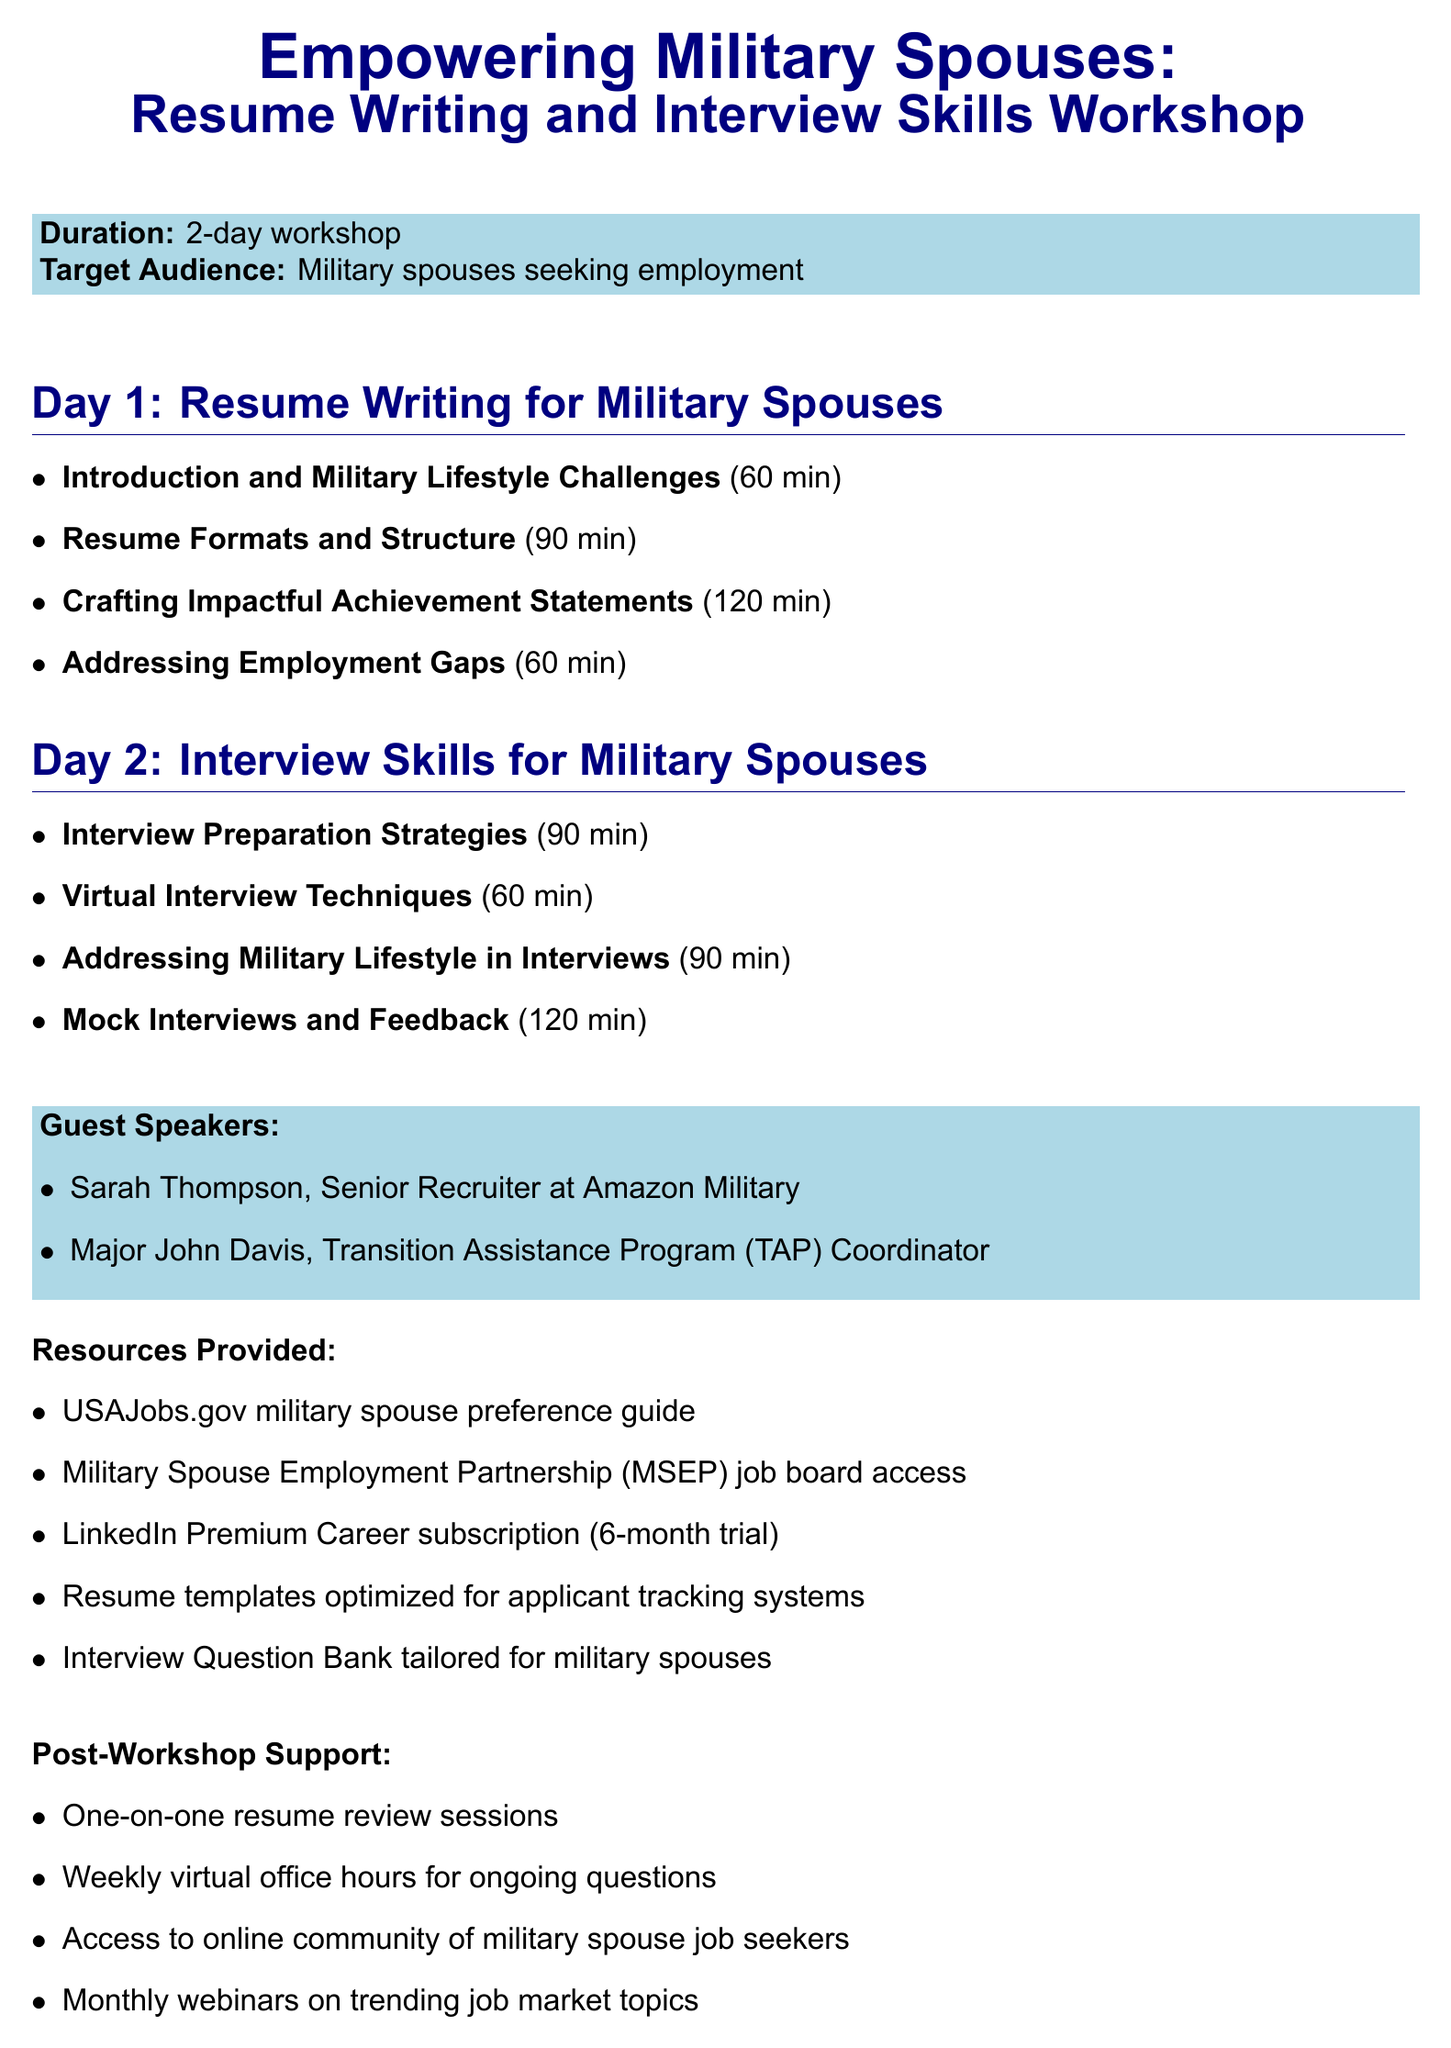What is the title of the workshop? The title of the workshop is clearly stated at the top of the document.
Answer: Empowering Military Spouses: Resume Writing and Interview Skills Workshop How long is the workshop scheduled for? The duration of the workshop is specified in the introductory section of the document.
Answer: 2-day workshop Who is the target audience for the workshop? The target audience is defined in the details of the document.
Answer: Military spouses seeking employment What is the duration of the session "Crafting Impactful Achievement Statements"? The duration of the session can be found under the respective section for Day 1.
Answer: 120 minutes Who is one of the guest speakers at the workshop? The guest speakers are listed in the section dedicated to them.
Answer: Sarah Thompson What is one resource provided to attendees? The resources provided are outlined in the specific section about resources.
Answer: USAJobs.gov military spouse preference guide What method is suggested for crafting achievement statements? The method is mentioned in the session details for Day 1.
Answer: STAR method How many minutes are allocated for the "Mock Interviews and Feedback" session? The duration can be found in the schedule for Day 2.
Answer: 120 minutes What type of support is offered after the workshop? Post-workshop support details are listed in their respective section.
Answer: One-on-one resume review sessions 